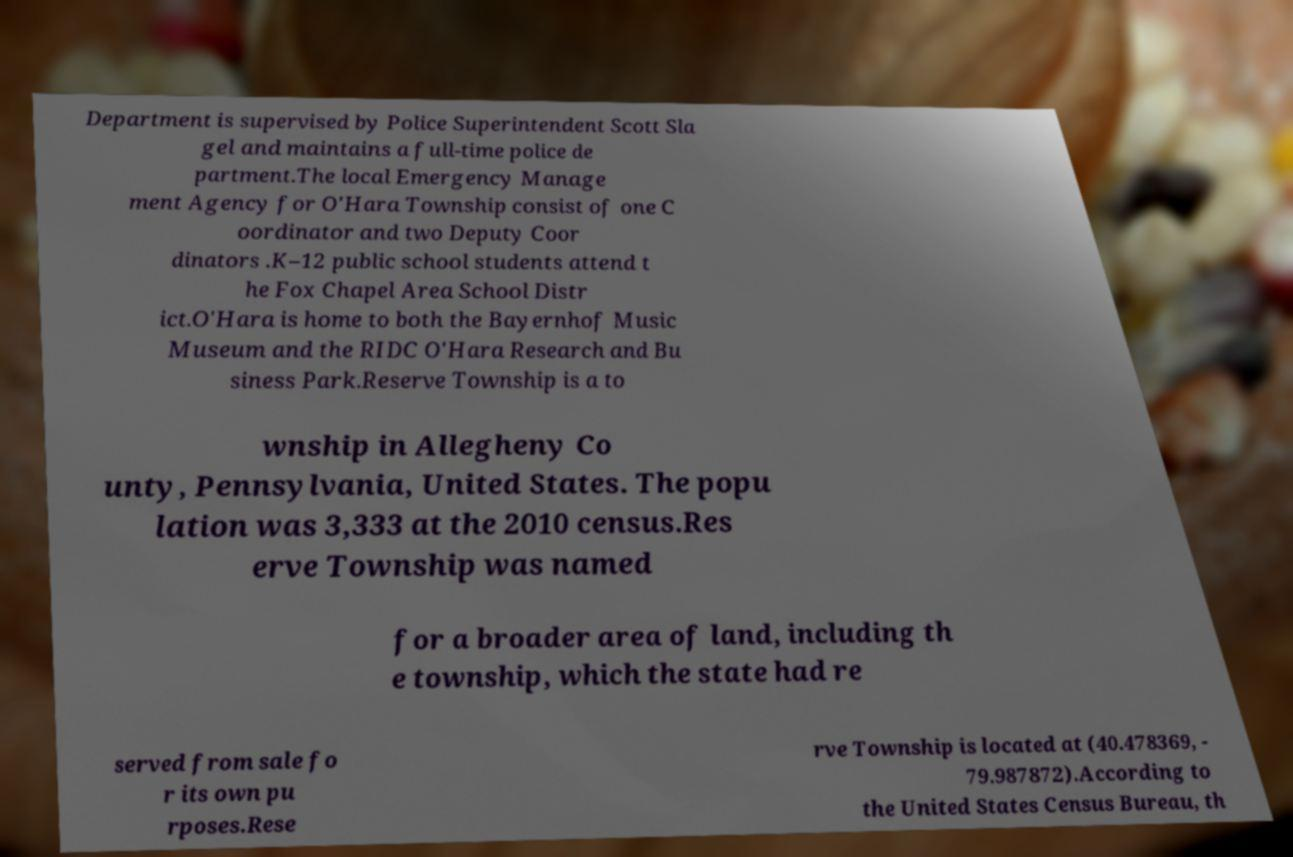Could you extract and type out the text from this image? Department is supervised by Police Superintendent Scott Sla gel and maintains a full-time police de partment.The local Emergency Manage ment Agency for O'Hara Township consist of one C oordinator and two Deputy Coor dinators .K–12 public school students attend t he Fox Chapel Area School Distr ict.O'Hara is home to both the Bayernhof Music Museum and the RIDC O'Hara Research and Bu siness Park.Reserve Township is a to wnship in Allegheny Co unty, Pennsylvania, United States. The popu lation was 3,333 at the 2010 census.Res erve Township was named for a broader area of land, including th e township, which the state had re served from sale fo r its own pu rposes.Rese rve Township is located at (40.478369, - 79.987872).According to the United States Census Bureau, th 